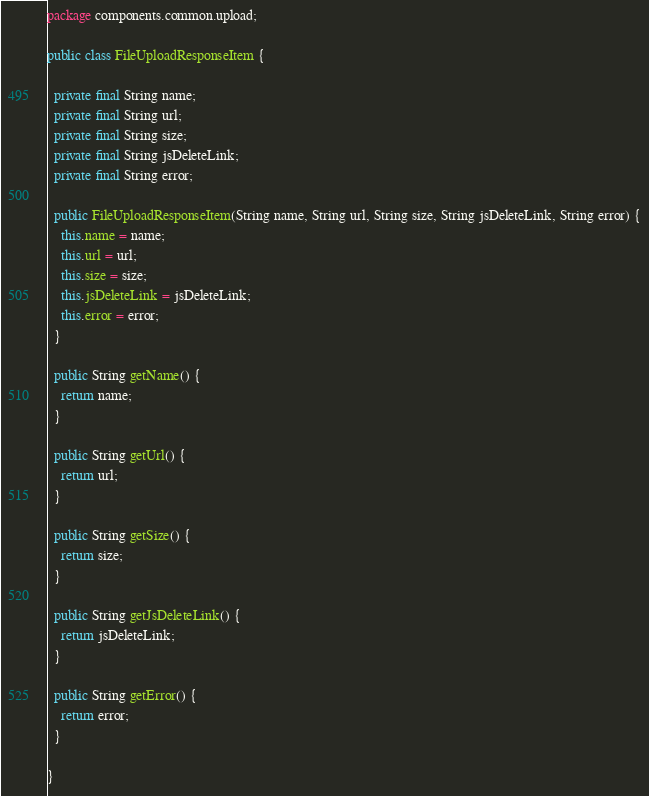Convert code to text. <code><loc_0><loc_0><loc_500><loc_500><_Java_>package components.common.upload;

public class FileUploadResponseItem {

  private final String name;
  private final String url;
  private final String size;
  private final String jsDeleteLink;
  private final String error;

  public FileUploadResponseItem(String name, String url, String size, String jsDeleteLink, String error) {
    this.name = name;
    this.url = url;
    this.size = size;
    this.jsDeleteLink = jsDeleteLink;
    this.error = error;
  }

  public String getName() {
    return name;
  }

  public String getUrl() {
    return url;
  }

  public String getSize() {
    return size;
  }

  public String getJsDeleteLink() {
    return jsDeleteLink;
  }

  public String getError() {
    return error;
  }

}
</code> 